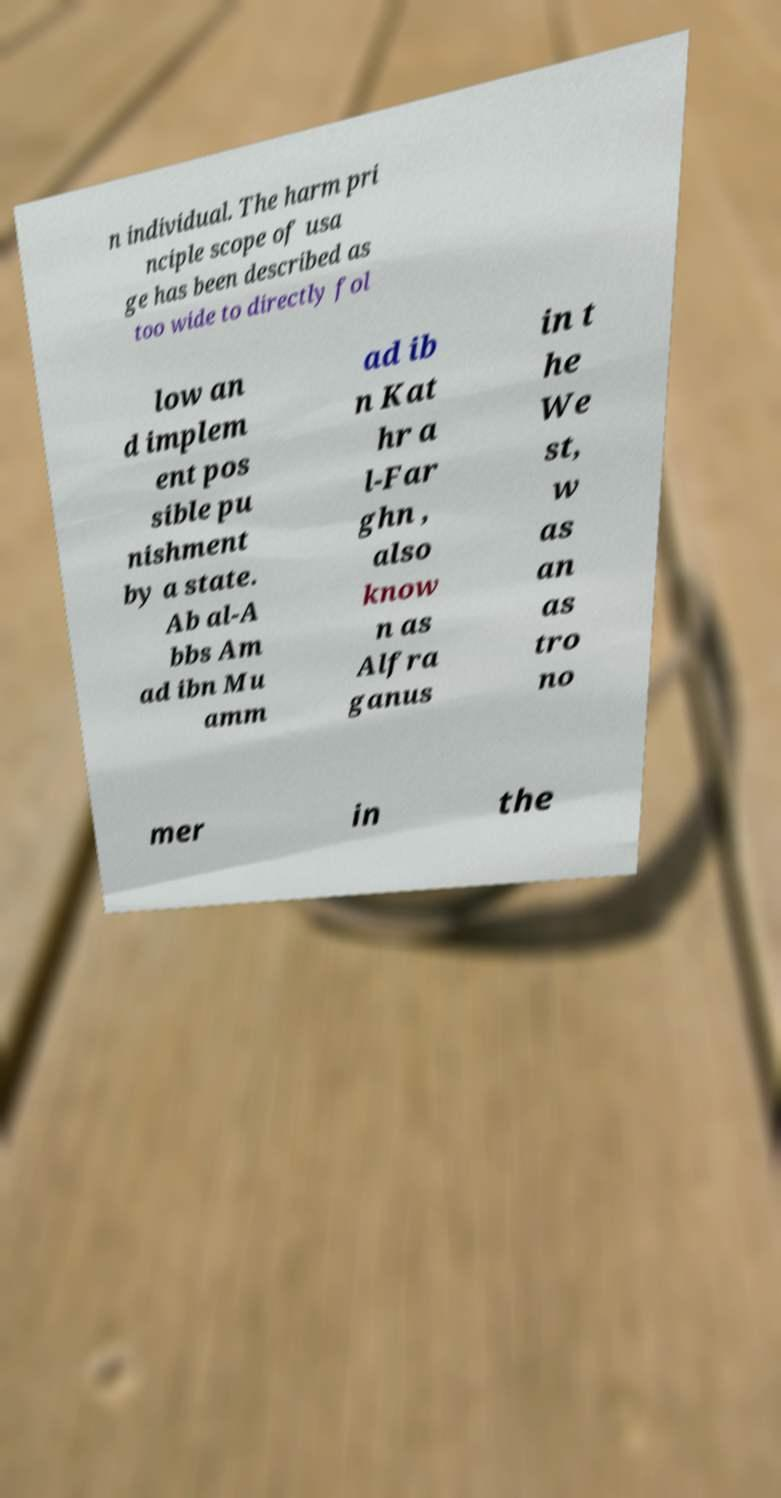Could you assist in decoding the text presented in this image and type it out clearly? n individual. The harm pri nciple scope of usa ge has been described as too wide to directly fol low an d implem ent pos sible pu nishment by a state. Ab al-A bbs Am ad ibn Mu amm ad ib n Kat hr a l-Far ghn , also know n as Alfra ganus in t he We st, w as an as tro no mer in the 